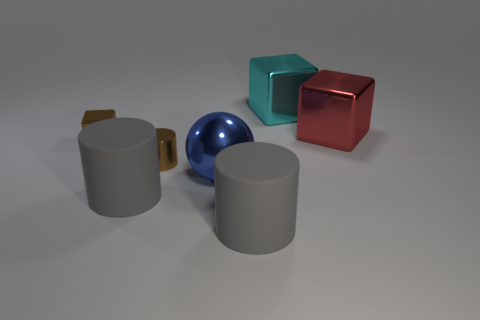What colors are the objects in the image? In the image, the objects display a variety of colors. There are two gray cylindrical objects, a blue sphere, a teal cube, and a reddish cube. 